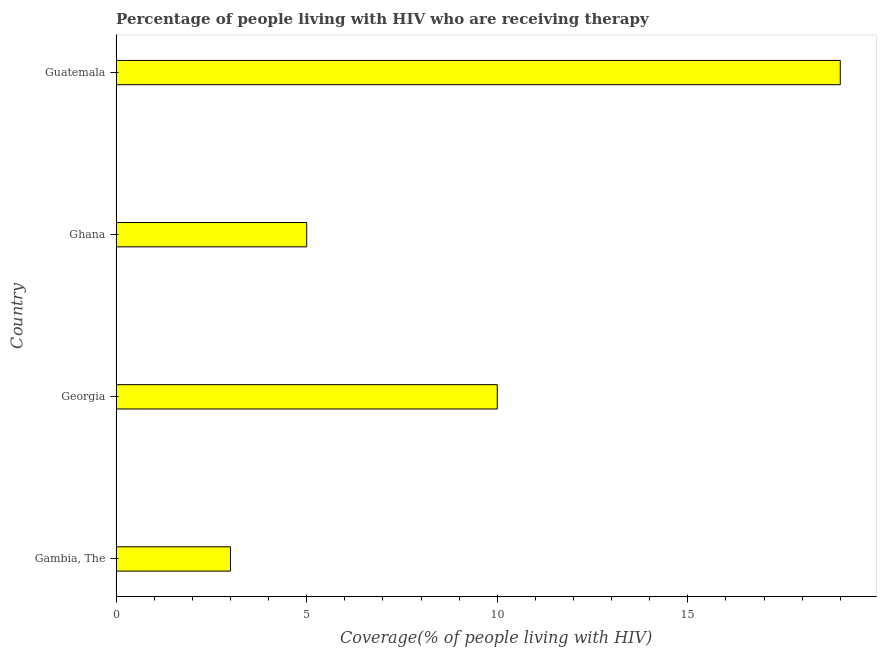Does the graph contain any zero values?
Your response must be concise. No. What is the title of the graph?
Provide a short and direct response. Percentage of people living with HIV who are receiving therapy. What is the label or title of the X-axis?
Offer a very short reply. Coverage(% of people living with HIV). Across all countries, what is the maximum antiretroviral therapy coverage?
Offer a very short reply. 19. Across all countries, what is the minimum antiretroviral therapy coverage?
Give a very brief answer. 3. In which country was the antiretroviral therapy coverage maximum?
Offer a very short reply. Guatemala. In which country was the antiretroviral therapy coverage minimum?
Your answer should be very brief. Gambia, The. What is the average antiretroviral therapy coverage per country?
Give a very brief answer. 9.25. What is the median antiretroviral therapy coverage?
Keep it short and to the point. 7.5. In how many countries, is the antiretroviral therapy coverage greater than 7 %?
Give a very brief answer. 2. What is the ratio of the antiretroviral therapy coverage in Gambia, The to that in Georgia?
Your response must be concise. 0.3. Is the antiretroviral therapy coverage in Gambia, The less than that in Ghana?
Your response must be concise. Yes. Is the difference between the antiretroviral therapy coverage in Georgia and Ghana greater than the difference between any two countries?
Your answer should be very brief. No. In how many countries, is the antiretroviral therapy coverage greater than the average antiretroviral therapy coverage taken over all countries?
Offer a very short reply. 2. How many bars are there?
Provide a short and direct response. 4. Are all the bars in the graph horizontal?
Ensure brevity in your answer.  Yes. How many countries are there in the graph?
Provide a short and direct response. 4. Are the values on the major ticks of X-axis written in scientific E-notation?
Provide a succinct answer. No. What is the Coverage(% of people living with HIV) of Georgia?
Provide a succinct answer. 10. What is the Coverage(% of people living with HIV) of Ghana?
Give a very brief answer. 5. What is the Coverage(% of people living with HIV) in Guatemala?
Keep it short and to the point. 19. What is the difference between the Coverage(% of people living with HIV) in Gambia, The and Ghana?
Offer a terse response. -2. What is the ratio of the Coverage(% of people living with HIV) in Gambia, The to that in Georgia?
Keep it short and to the point. 0.3. What is the ratio of the Coverage(% of people living with HIV) in Gambia, The to that in Guatemala?
Offer a very short reply. 0.16. What is the ratio of the Coverage(% of people living with HIV) in Georgia to that in Ghana?
Your response must be concise. 2. What is the ratio of the Coverage(% of people living with HIV) in Georgia to that in Guatemala?
Your answer should be very brief. 0.53. What is the ratio of the Coverage(% of people living with HIV) in Ghana to that in Guatemala?
Give a very brief answer. 0.26. 